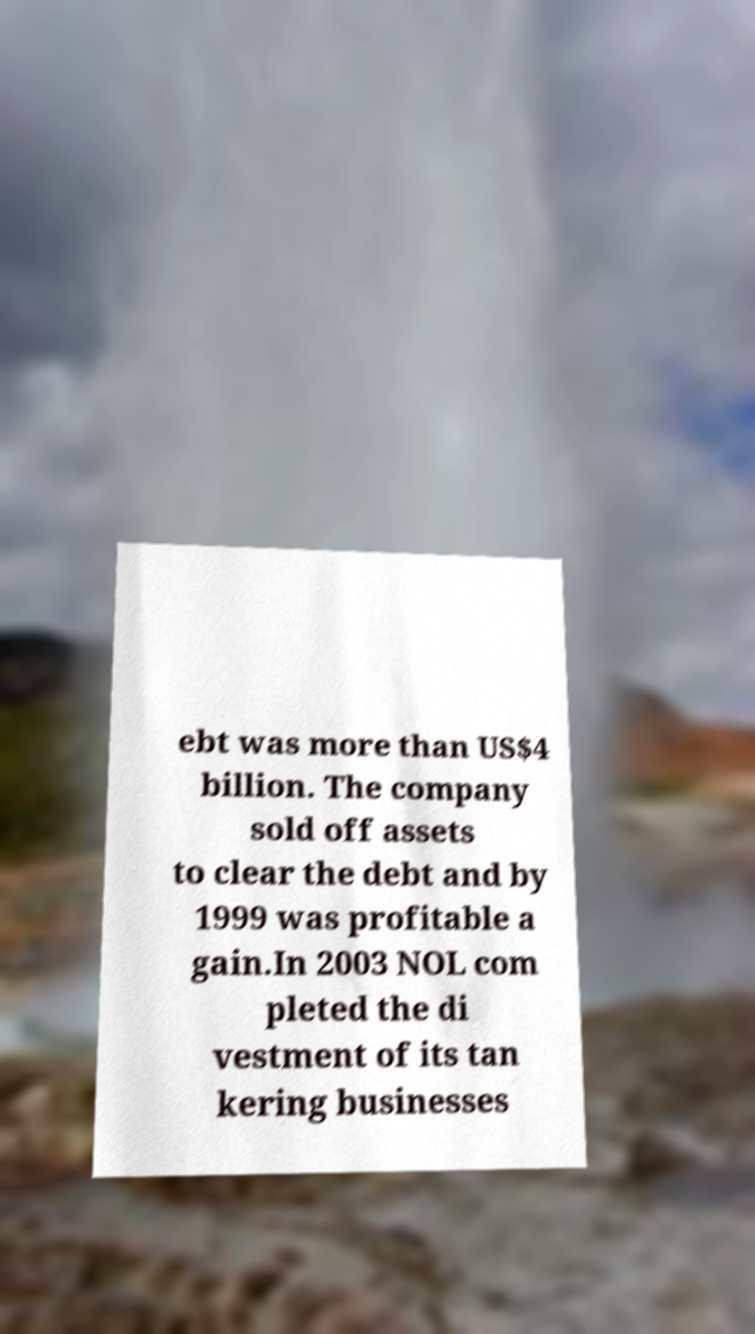Please identify and transcribe the text found in this image. ebt was more than US$4 billion. The company sold off assets to clear the debt and by 1999 was profitable a gain.In 2003 NOL com pleted the di vestment of its tan kering businesses 